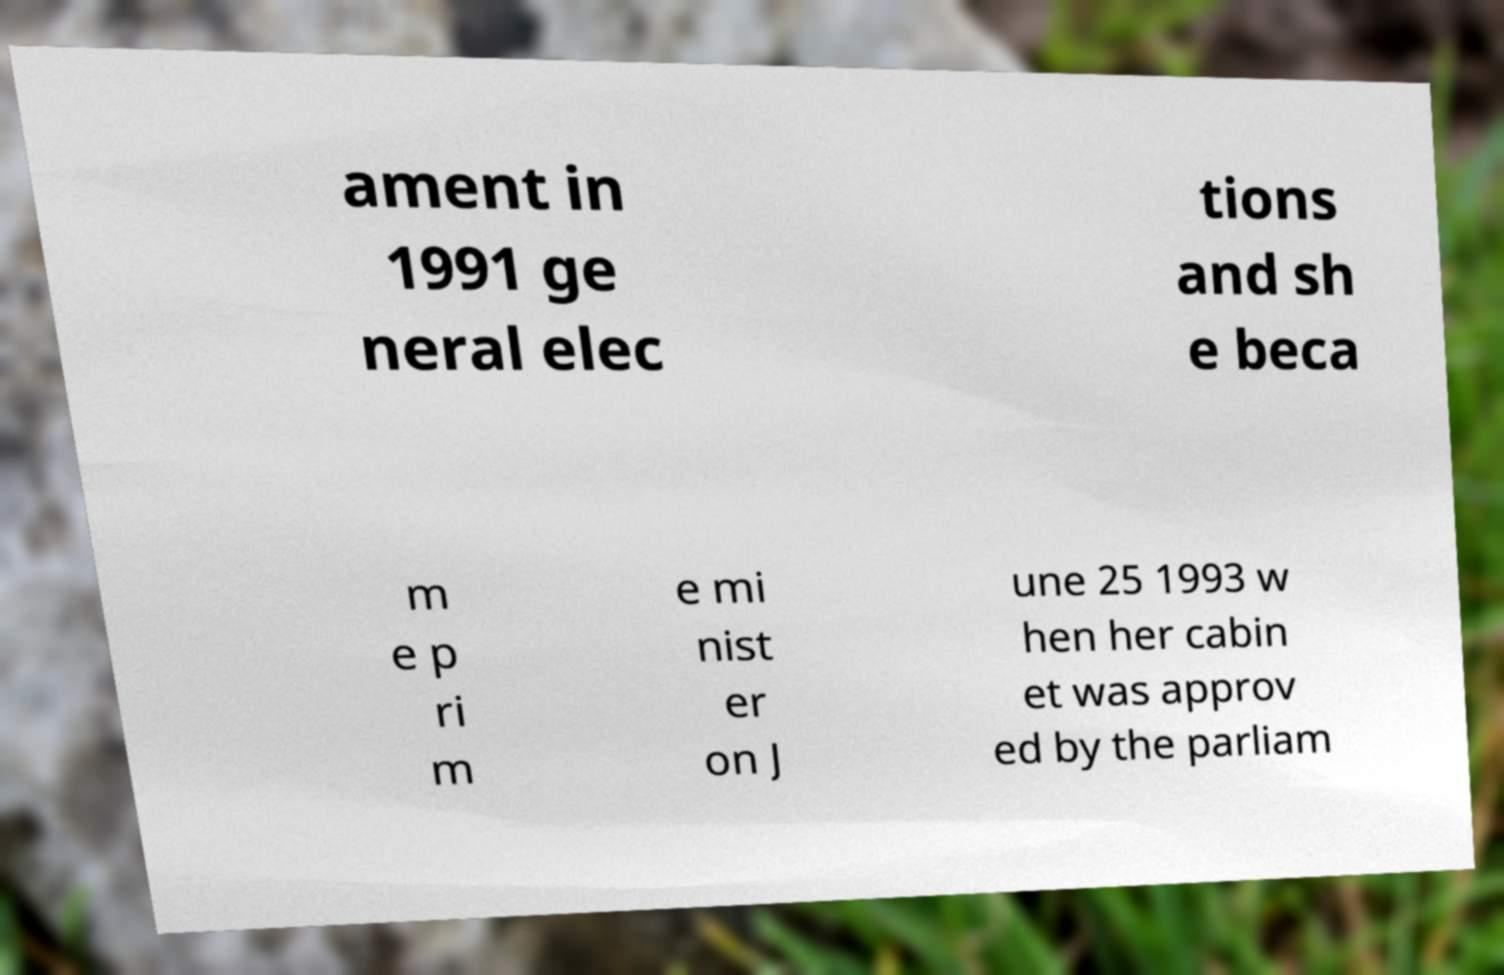Could you extract and type out the text from this image? ament in 1991 ge neral elec tions and sh e beca m e p ri m e mi nist er on J une 25 1993 w hen her cabin et was approv ed by the parliam 